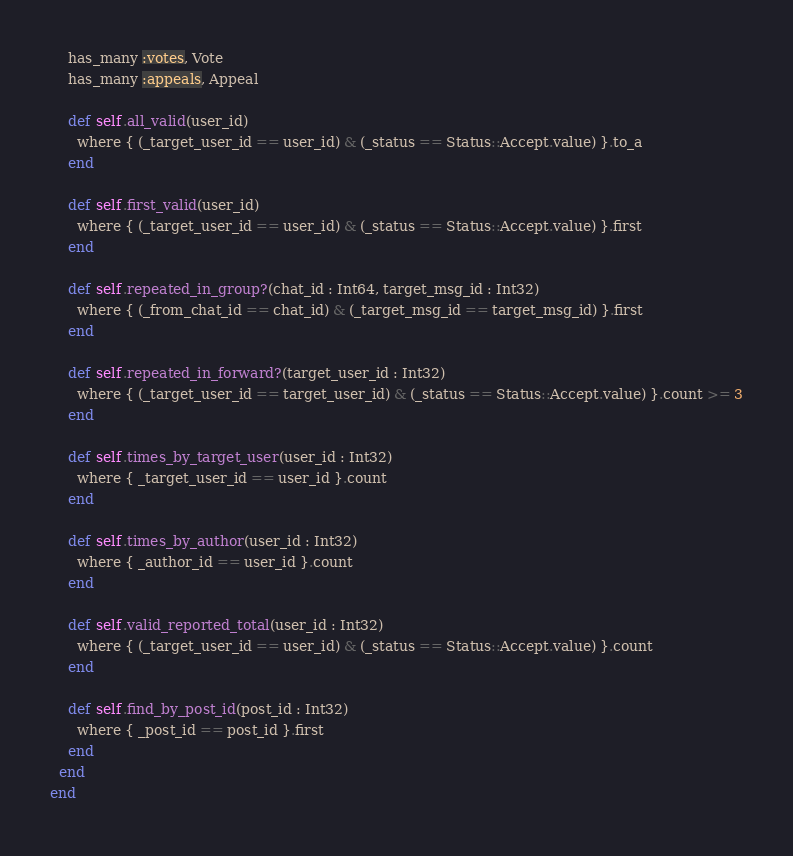Convert code to text. <code><loc_0><loc_0><loc_500><loc_500><_Crystal_>    has_many :votes, Vote
    has_many :appeals, Appeal

    def self.all_valid(user_id)
      where { (_target_user_id == user_id) & (_status == Status::Accept.value) }.to_a
    end

    def self.first_valid(user_id)
      where { (_target_user_id == user_id) & (_status == Status::Accept.value) }.first
    end

    def self.repeated_in_group?(chat_id : Int64, target_msg_id : Int32)
      where { (_from_chat_id == chat_id) & (_target_msg_id == target_msg_id) }.first
    end

    def self.repeated_in_forward?(target_user_id : Int32)
      where { (_target_user_id == target_user_id) & (_status == Status::Accept.value) }.count >= 3
    end

    def self.times_by_target_user(user_id : Int32)
      where { _target_user_id == user_id }.count
    end

    def self.times_by_author(user_id : Int32)
      where { _author_id == user_id }.count
    end

    def self.valid_reported_total(user_id : Int32)
      where { (_target_user_id == user_id) & (_status == Status::Accept.value) }.count
    end

    def self.find_by_post_id(post_id : Int32)
      where { _post_id == post_id }.first
    end
  end
end
</code> 